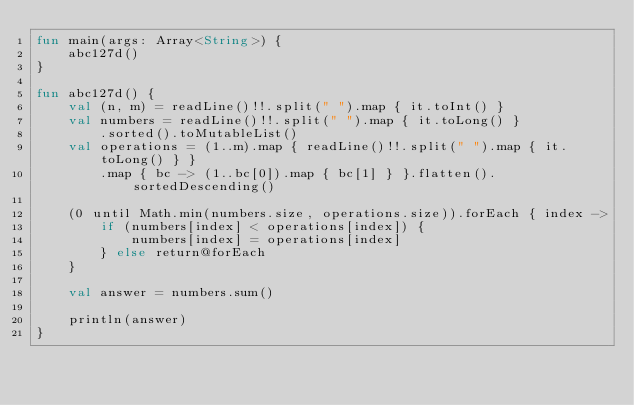<code> <loc_0><loc_0><loc_500><loc_500><_Kotlin_>fun main(args: Array<String>) {
    abc127d()
}

fun abc127d() {
    val (n, m) = readLine()!!.split(" ").map { it.toInt() }
    val numbers = readLine()!!.split(" ").map { it.toLong() }
        .sorted().toMutableList()
    val operations = (1..m).map { readLine()!!.split(" ").map { it.toLong() } }
        .map { bc -> (1..bc[0]).map { bc[1] } }.flatten().sortedDescending()

    (0 until Math.min(numbers.size, operations.size)).forEach { index ->
        if (numbers[index] < operations[index]) {
            numbers[index] = operations[index]
        } else return@forEach
    }

    val answer = numbers.sum()

    println(answer)
}
</code> 